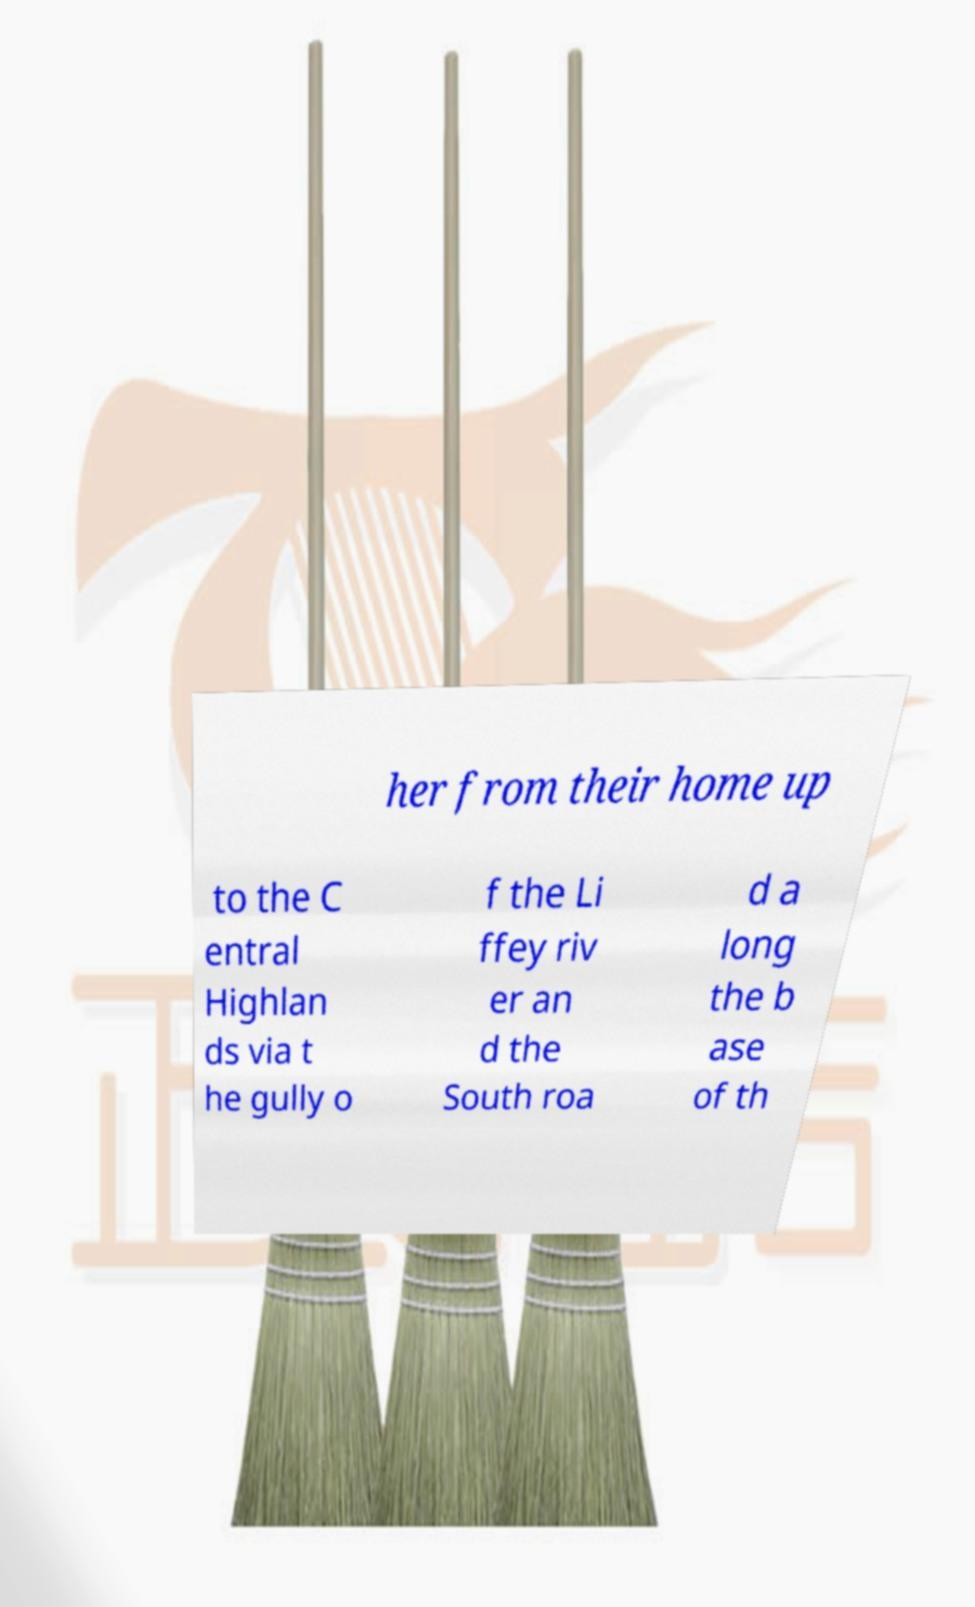I need the written content from this picture converted into text. Can you do that? her from their home up to the C entral Highlan ds via t he gully o f the Li ffey riv er an d the South roa d a long the b ase of th 